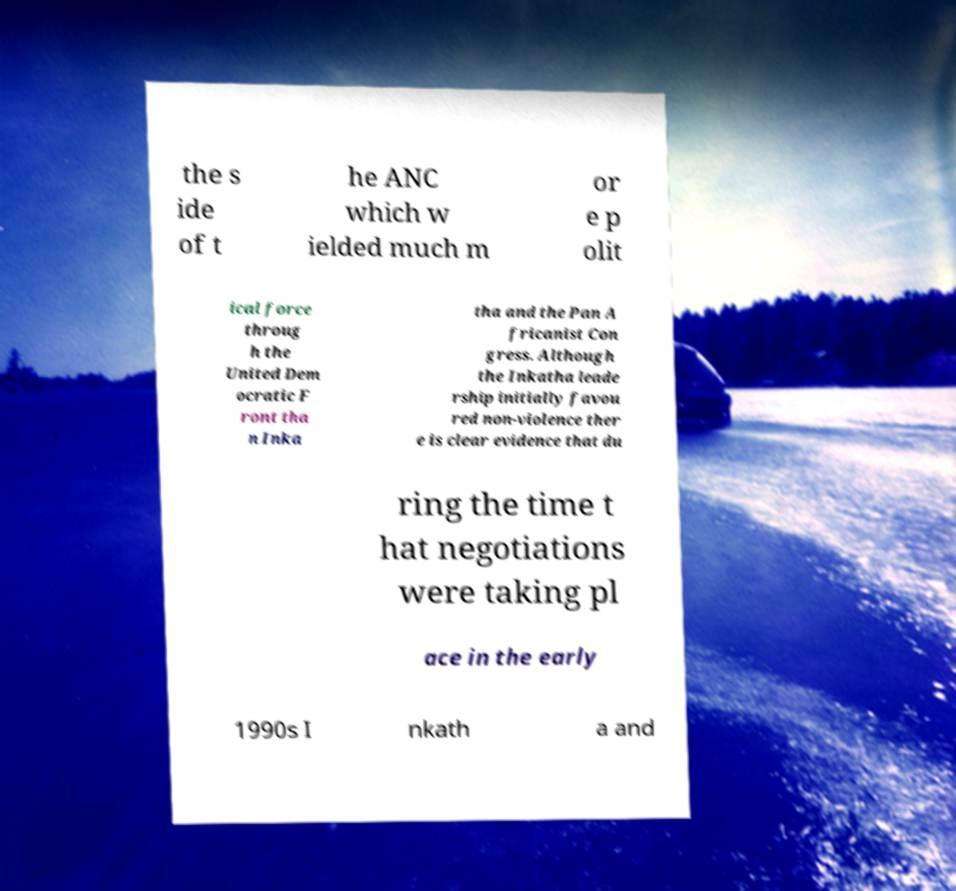Please read and relay the text visible in this image. What does it say? the s ide of t he ANC which w ielded much m or e p olit ical force throug h the United Dem ocratic F ront tha n Inka tha and the Pan A fricanist Con gress. Although the Inkatha leade rship initially favou red non-violence ther e is clear evidence that du ring the time t hat negotiations were taking pl ace in the early 1990s I nkath a and 